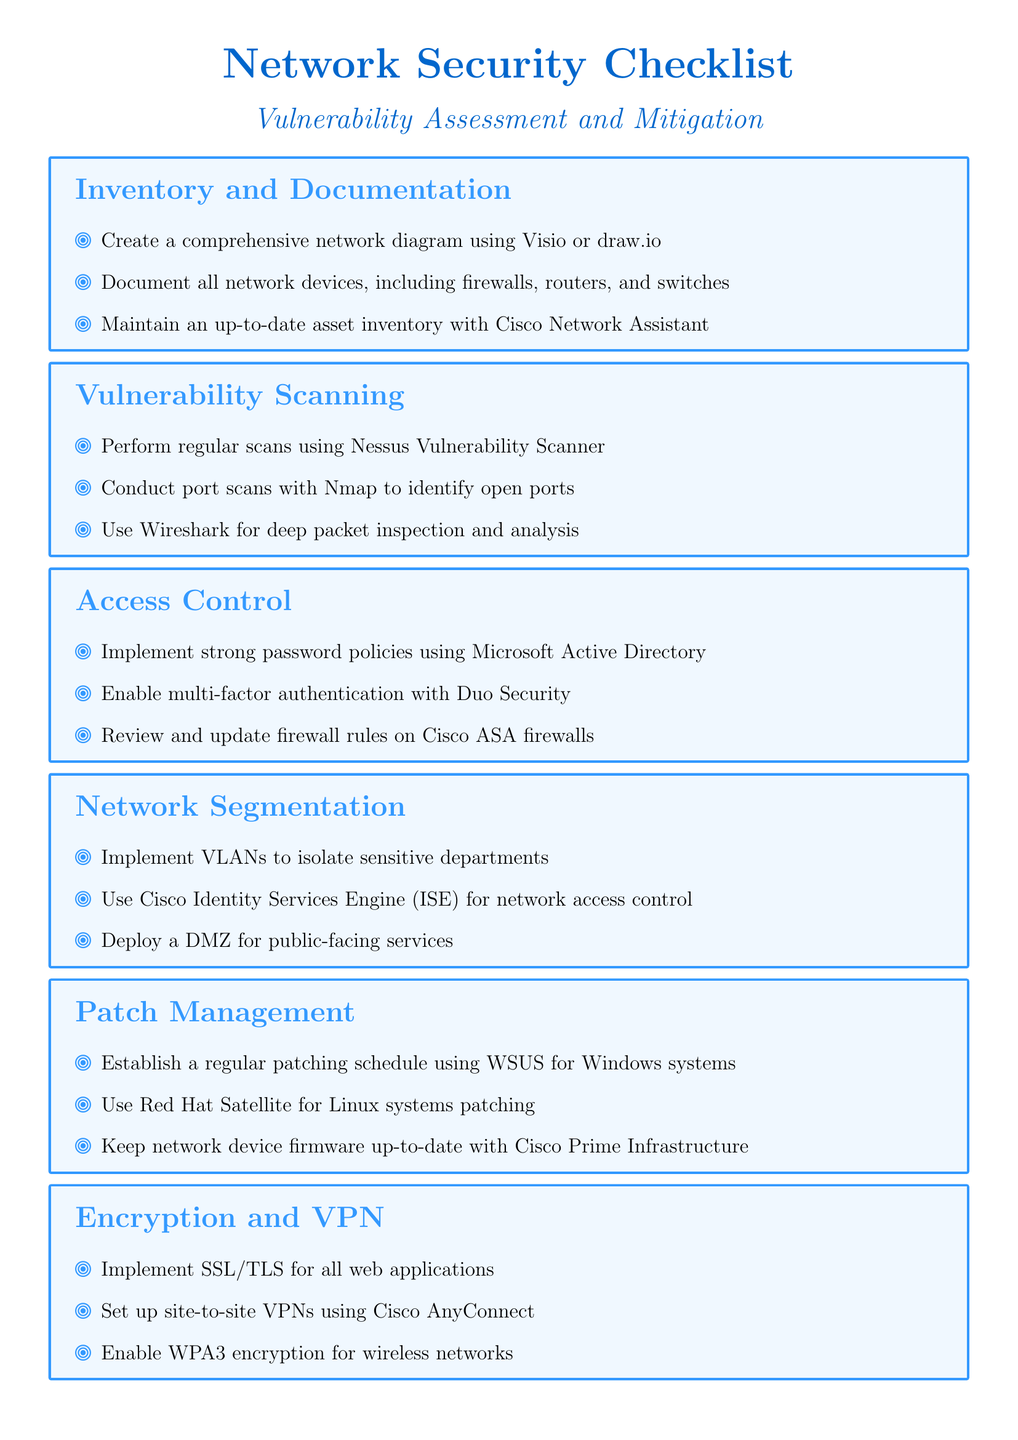What is the first step in inventory and documentation? The first step is creating a comprehensive network diagram using Visio or draw.io.
Answer: Creating a comprehensive network diagram using Visio or draw.io What tool is recommended for regular vulnerability scanning? The document recommends using Nessus Vulnerability Scanner for regular scans.
Answer: Nessus Vulnerability Scanner What type of authentication is suggested to be enabled? The checklist suggests enabling multi-factor authentication with Duo Security.
Answer: Multi-factor authentication with Duo Security What is one method for network segmentation? One method for network segmentation is implementing VLANs to isolate sensitive departments.
Answer: Implementing VLANs to isolate sensitive departments What frequency is recommended for patch management? The document suggests establishing a regular patching schedule.
Answer: Regular patching schedule What encryption standard should be enabled for wireless networks? The checklist recommends enabling WPA3 encryption for wireless networks.
Answer: WPA3 encryption What is a primary function of a SIEM solution like Splunk? A primary function is log aggregation and analysis.
Answer: Log aggregation and analysis What incident response activity is suggested in the document? The document suggests establishing an incident response plan and conducting regular drills.
Answer: Establishing an incident response plan and conducting regular drills 